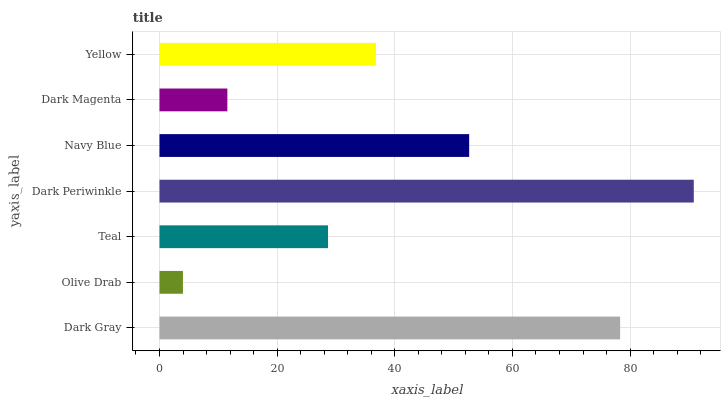Is Olive Drab the minimum?
Answer yes or no. Yes. Is Dark Periwinkle the maximum?
Answer yes or no. Yes. Is Teal the minimum?
Answer yes or no. No. Is Teal the maximum?
Answer yes or no. No. Is Teal greater than Olive Drab?
Answer yes or no. Yes. Is Olive Drab less than Teal?
Answer yes or no. Yes. Is Olive Drab greater than Teal?
Answer yes or no. No. Is Teal less than Olive Drab?
Answer yes or no. No. Is Yellow the high median?
Answer yes or no. Yes. Is Yellow the low median?
Answer yes or no. Yes. Is Dark Magenta the high median?
Answer yes or no. No. Is Navy Blue the low median?
Answer yes or no. No. 